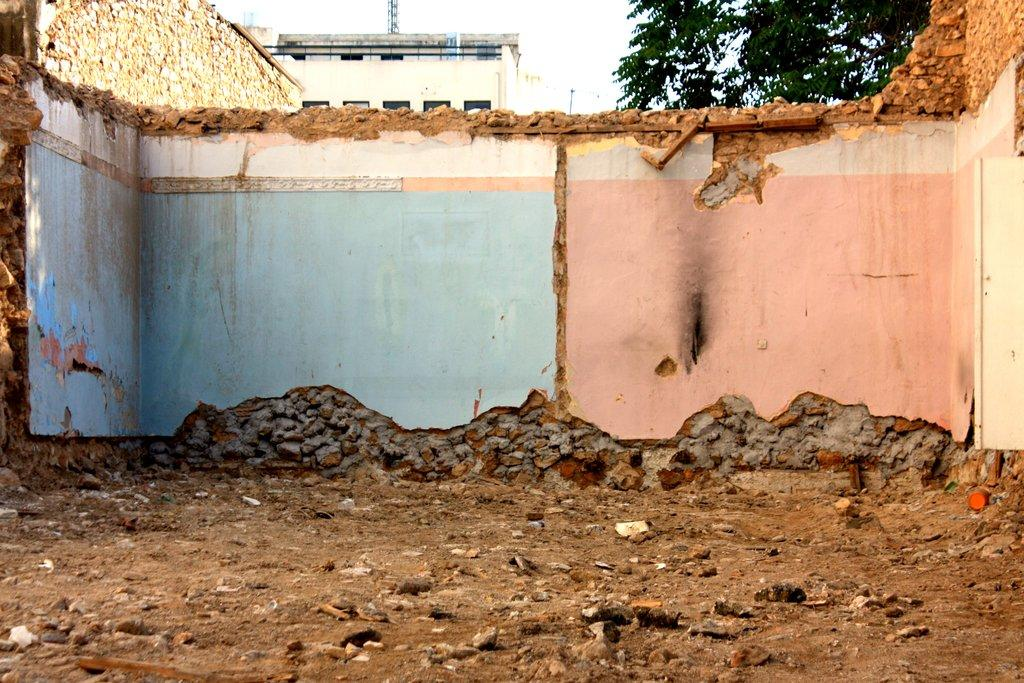What is located in the center of the image? There is a wall in the center of the image. What is at the bottom of the image? There is sand at the bottom of the image. What can be seen in the background of the image? There are houses and trees in the background of the image. What flavor of smoke can be seen coming from the chimneys of the houses in the image? There is no smoke visible in the image, and therefore no flavor can be determined. 